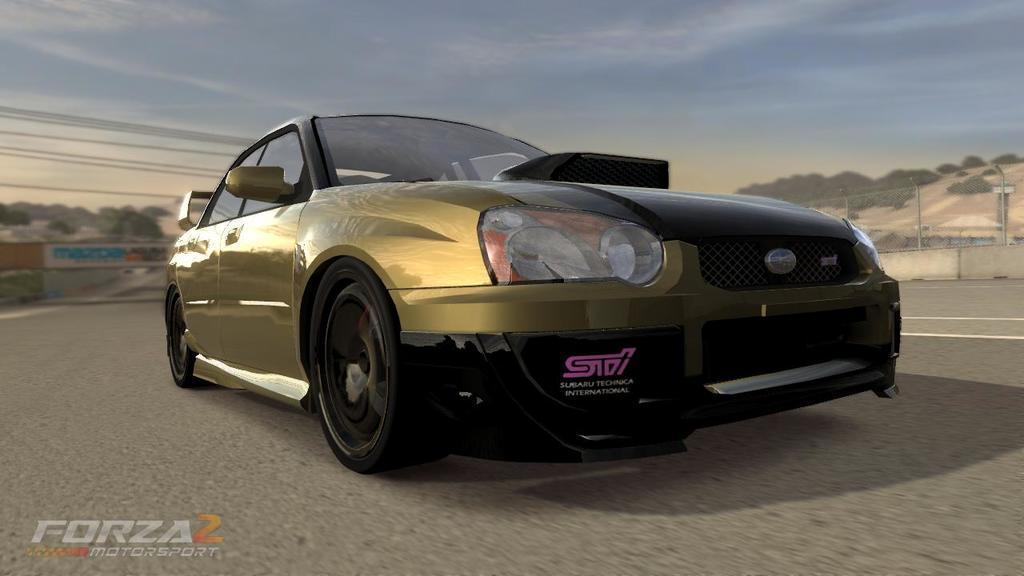Could you give a brief overview of what you see in this image? In this picture we can see a car in the front, on the left side there are wires, we can see a blurry background, there is some text at the left bottom, on the right side there are some places, we can see the sky at the top of the picture. 